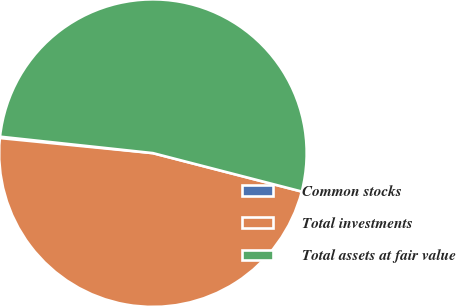Convert chart. <chart><loc_0><loc_0><loc_500><loc_500><pie_chart><fcel>Common stocks<fcel>Total investments<fcel>Total assets at fair value<nl><fcel>0.14%<fcel>47.54%<fcel>52.31%<nl></chart> 